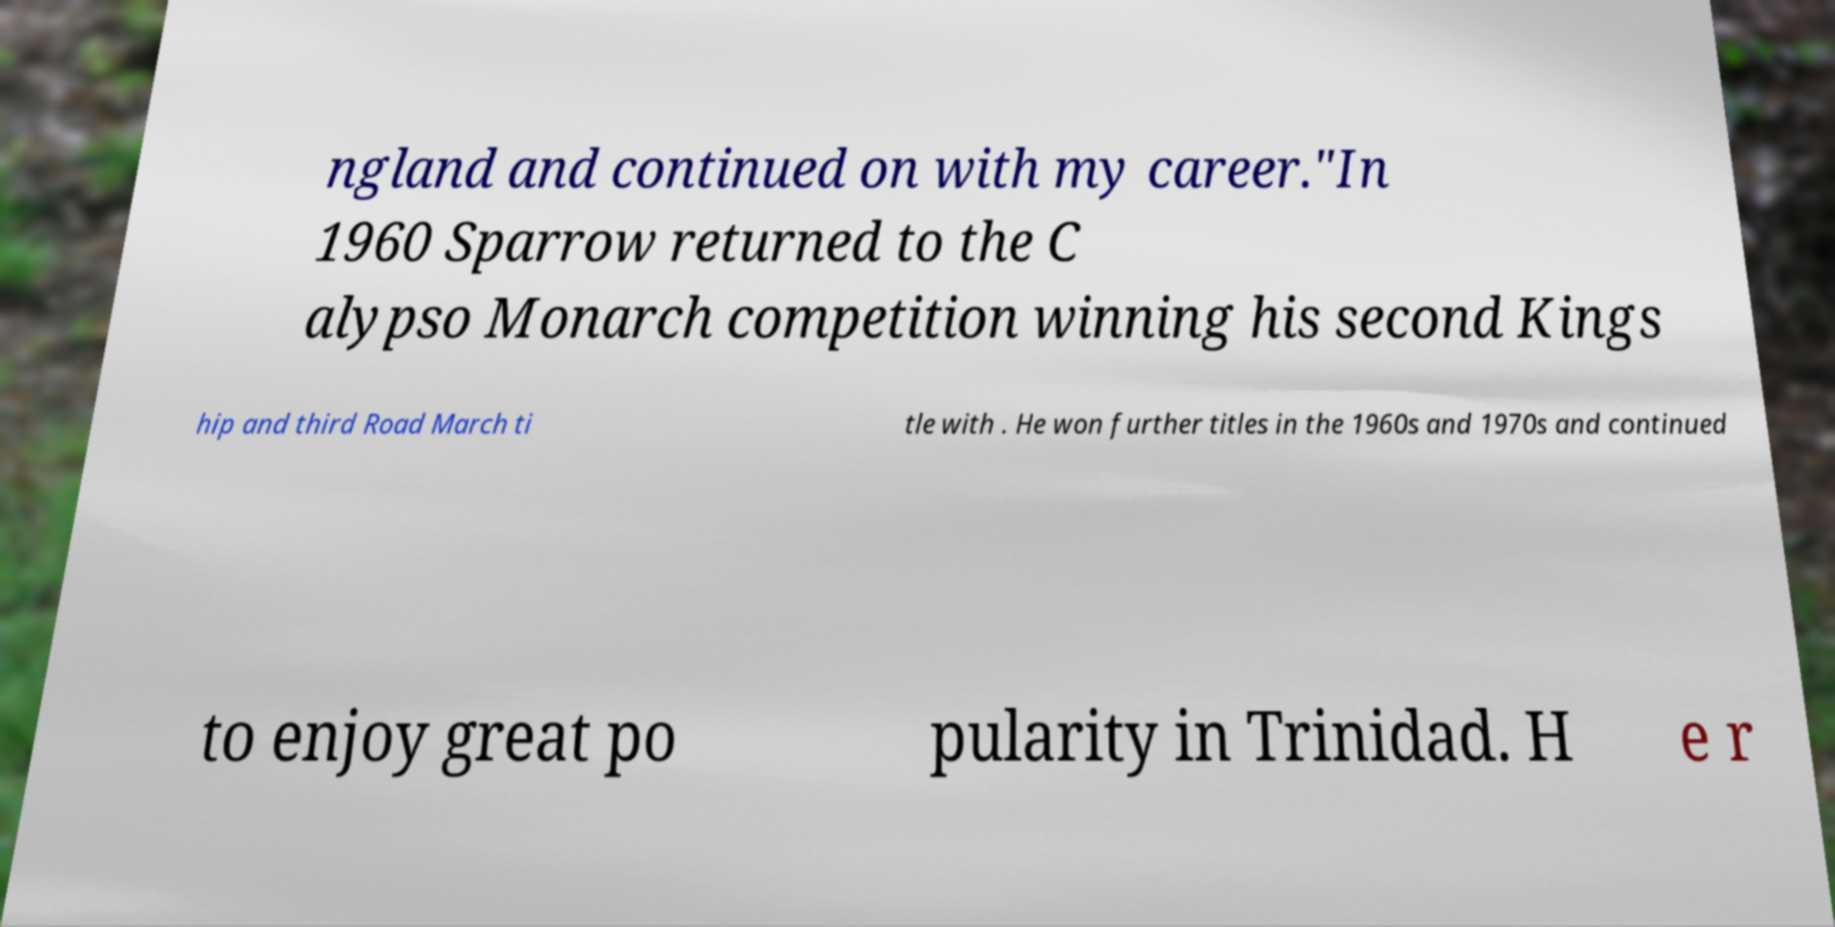Please identify and transcribe the text found in this image. ngland and continued on with my career."In 1960 Sparrow returned to the C alypso Monarch competition winning his second Kings hip and third Road March ti tle with . He won further titles in the 1960s and 1970s and continued to enjoy great po pularity in Trinidad. H e r 